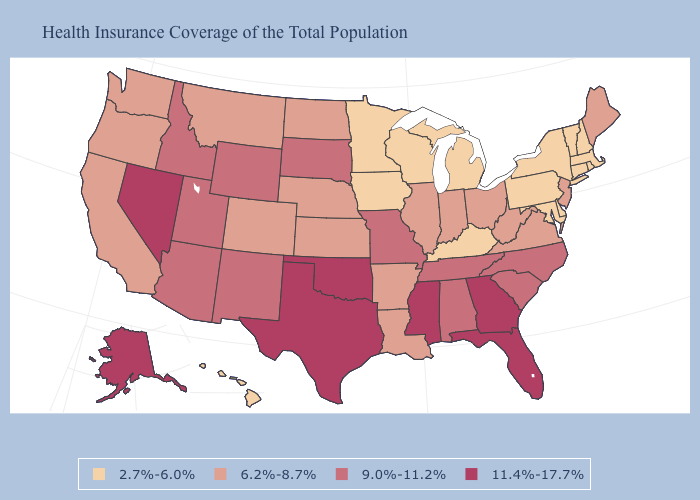Is the legend a continuous bar?
Write a very short answer. No. Does Nebraska have a lower value than South Dakota?
Quick response, please. Yes. Does the first symbol in the legend represent the smallest category?
Give a very brief answer. Yes. Among the states that border New York , does Vermont have the highest value?
Answer briefly. No. Among the states that border Massachusetts , which have the lowest value?
Keep it brief. Connecticut, New Hampshire, New York, Rhode Island, Vermont. Which states have the lowest value in the MidWest?
Write a very short answer. Iowa, Michigan, Minnesota, Wisconsin. What is the value of West Virginia?
Short answer required. 6.2%-8.7%. What is the lowest value in the MidWest?
Be succinct. 2.7%-6.0%. Does Arkansas have the lowest value in the USA?
Answer briefly. No. Which states hav the highest value in the West?
Short answer required. Alaska, Nevada. What is the value of Connecticut?
Answer briefly. 2.7%-6.0%. What is the highest value in the USA?
Be succinct. 11.4%-17.7%. Among the states that border Rhode Island , which have the highest value?
Short answer required. Connecticut, Massachusetts. Name the states that have a value in the range 11.4%-17.7%?
Keep it brief. Alaska, Florida, Georgia, Mississippi, Nevada, Oklahoma, Texas. Does the map have missing data?
Concise answer only. No. 